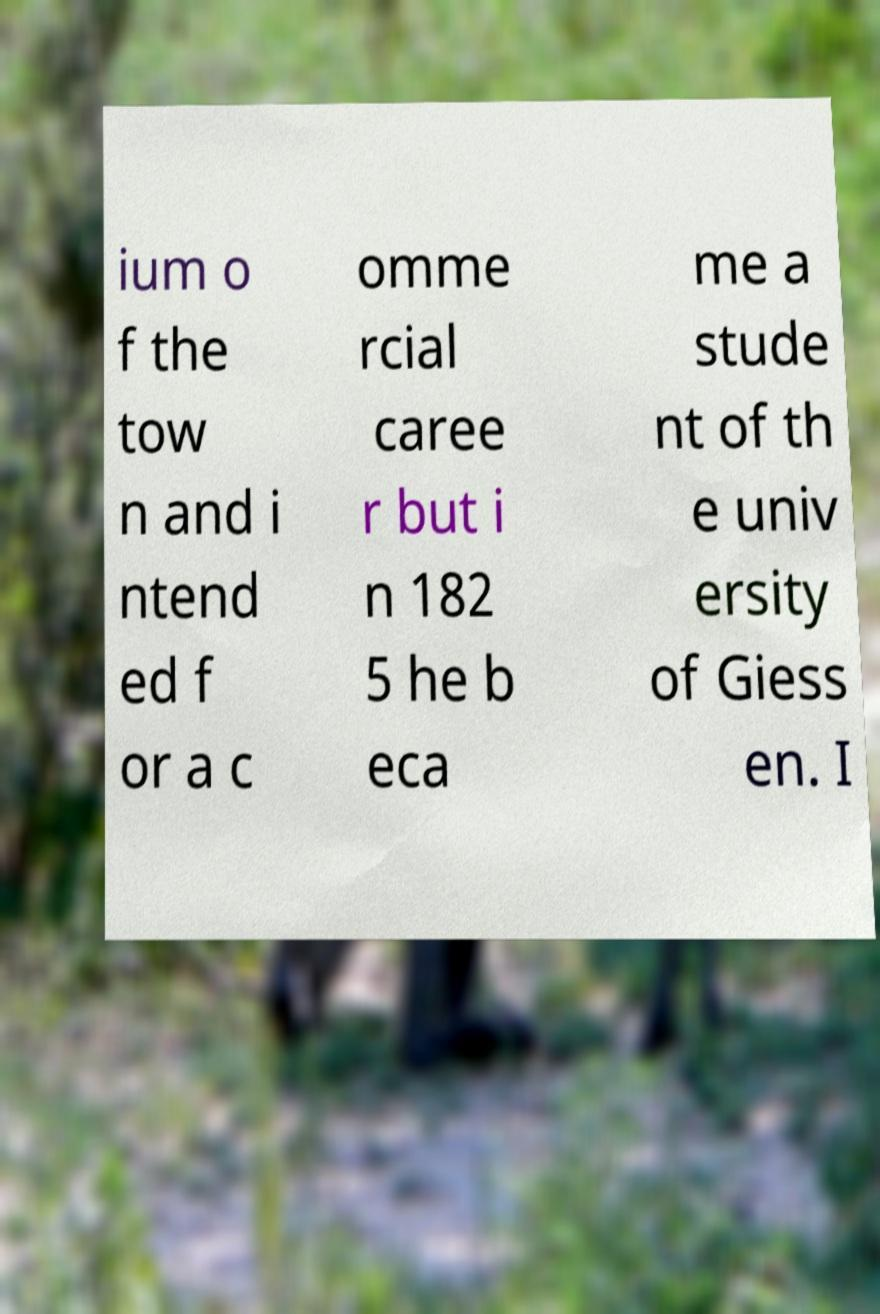Can you accurately transcribe the text from the provided image for me? ium o f the tow n and i ntend ed f or a c omme rcial caree r but i n 182 5 he b eca me a stude nt of th e univ ersity of Giess en. I 